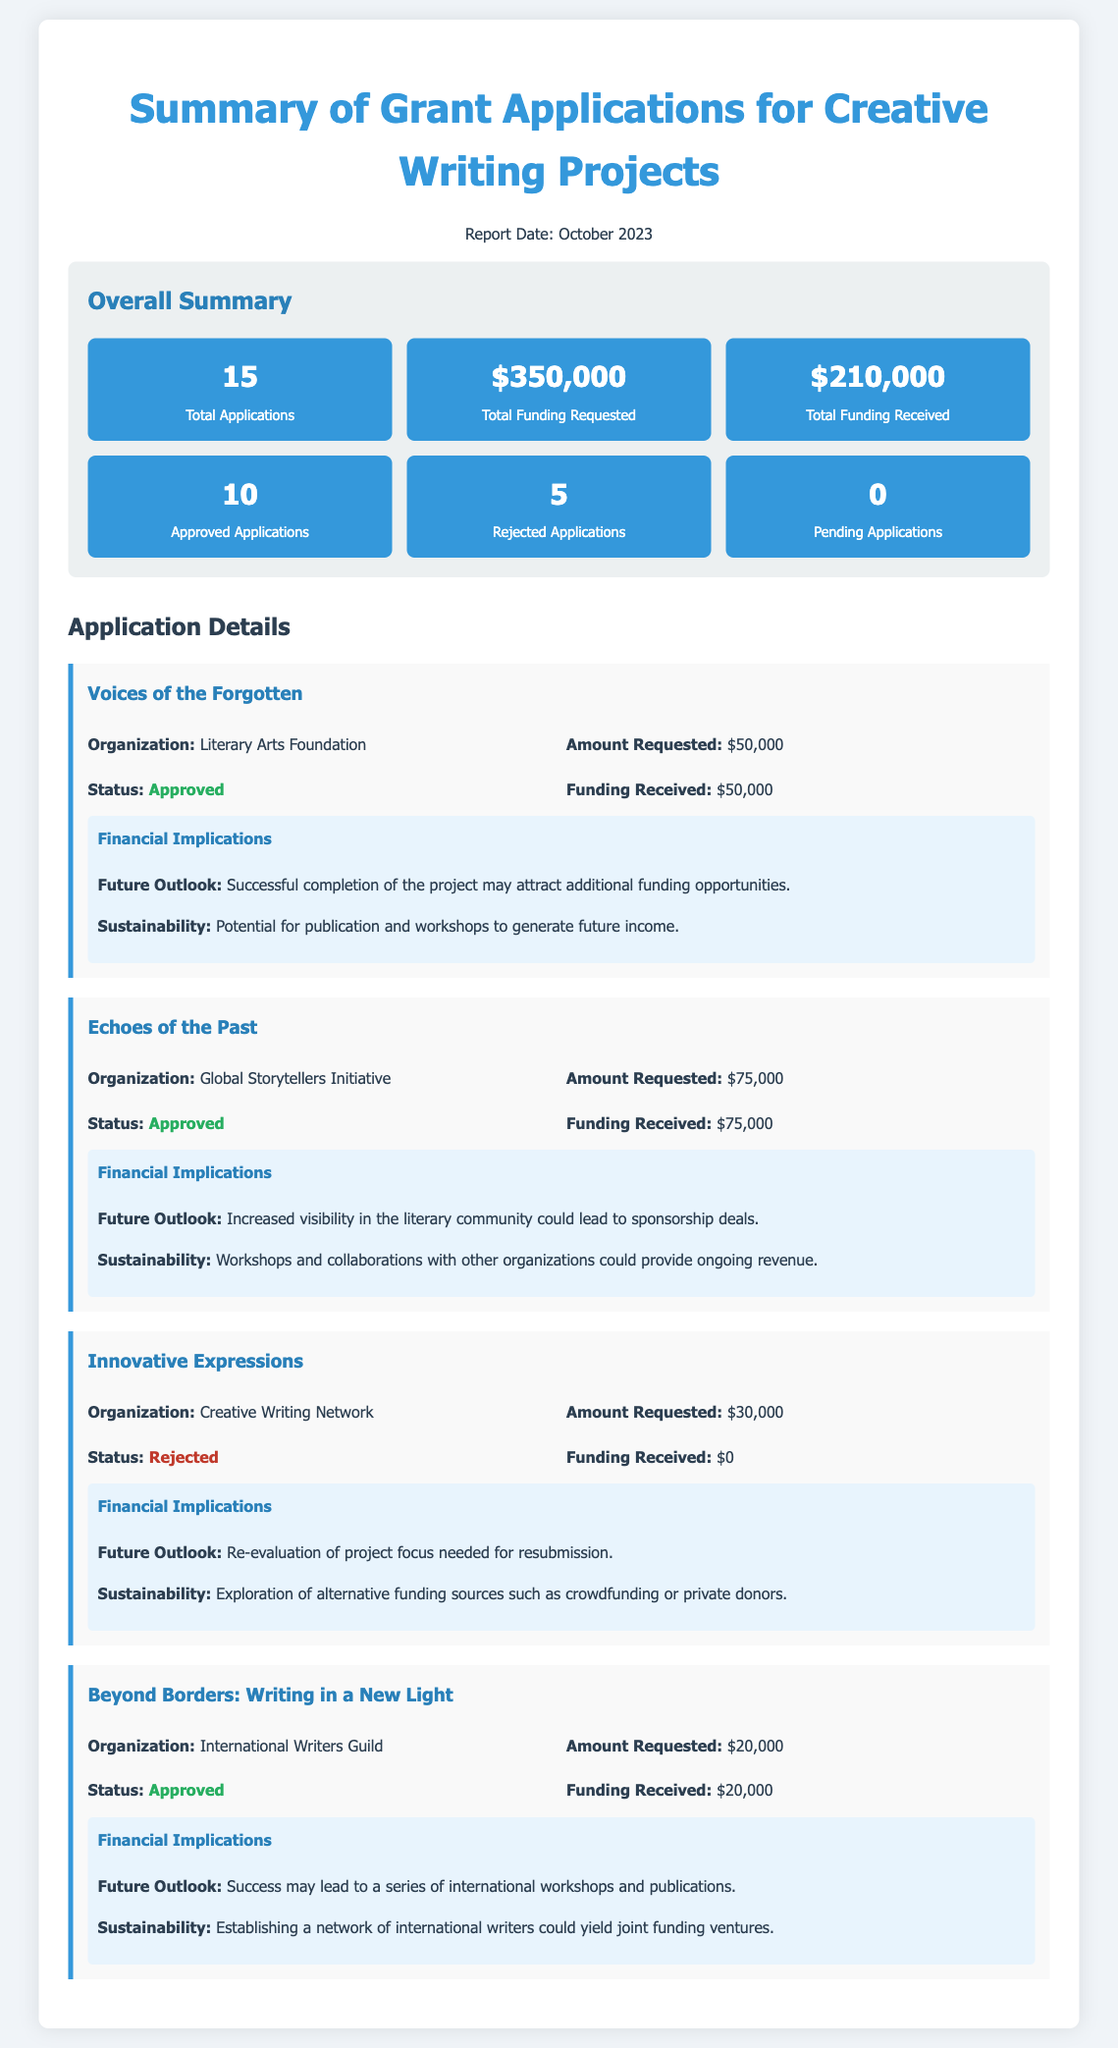What is the total number of grant applications submitted? The total number of grant applications is specified in the summary section of the document as 15.
Answer: 15 What is the total funding requested across all applications? The total funding requested is clearly stated in the document as $350,000 in the summary section.
Answer: $350,000 How much funding was received in total? The total funding received can be found in the summary and is listed as $210,000.
Answer: $210,000 How many applications were approved? The document indicates that 10 applications were approved, found in the summary section.
Answer: 10 What is the status of the application "Innovative Expressions"? The status of "Innovative Expressions" is mentioned as rejected in the application details.
Answer: Rejected What future outlook is mentioned for the application "Voices of the Forgotten"? The future outlook for "Voices of the Forgotten" is outlined in its implications section as attracting additional funding opportunities.
Answer: Additional funding opportunities Which organization submitted the application "Beyond Borders: Writing in a New Light"? The organization that submitted this application is specified as the International Writers Guild in the application details.
Answer: International Writers Guild What is the total amount received for the application "Echoes of the Past"? The amount received for "Echoes of the Past" is stated as $75,000 in its application details.
Answer: $75,000 What does the document state about the sustainability of the project "Innovative Expressions"? The sustainability section states the need for exploration of alternative funding sources for "Innovative Expressions."
Answer: Alternative funding sources 